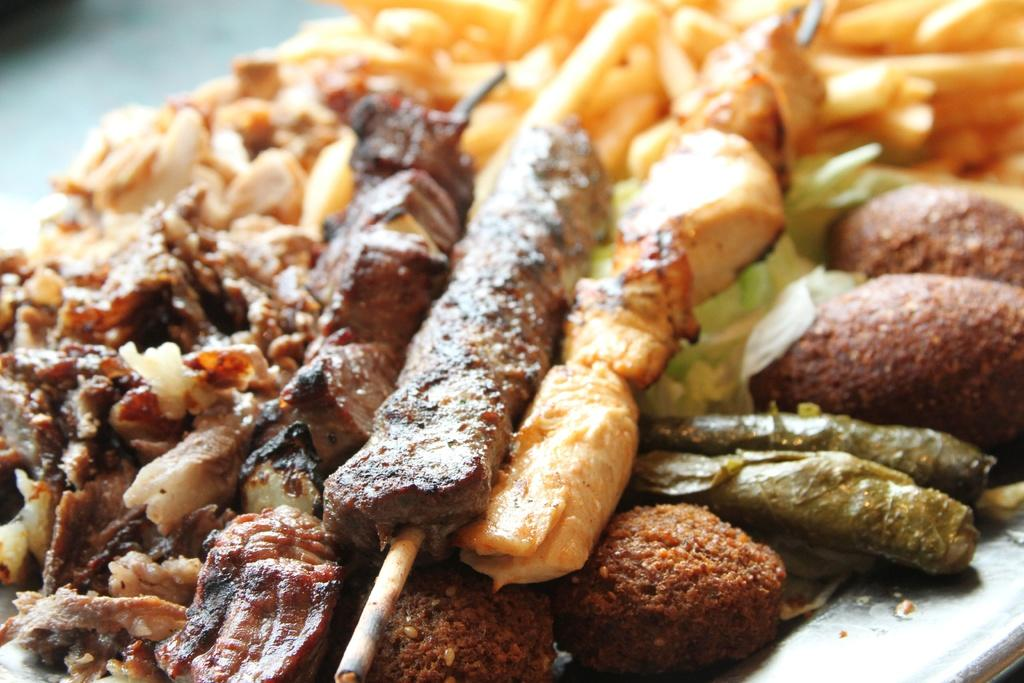What types of cooked food items can be seen in the image? There are different types of cooked food items in the image. How are the food items arranged or presented in the image? The food items are served on a plate. Can you tell me how many bats are flying around the food in the image? There are no bats present in the image; it only features cooked food items served on a plate. What type of birth ceremony is taking place in the image? There is no birth ceremony present in the image; it only features cooked food items served on a plate. 